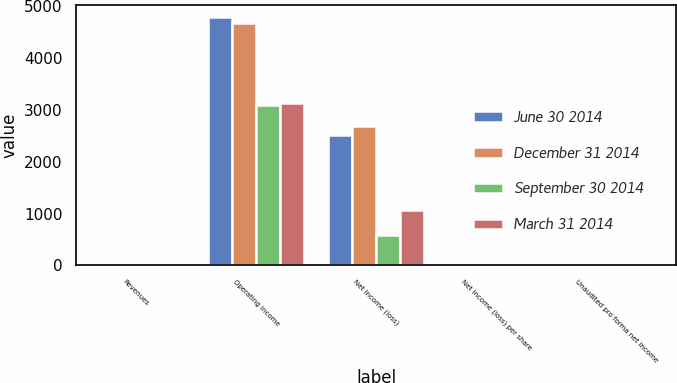<chart> <loc_0><loc_0><loc_500><loc_500><stacked_bar_chart><ecel><fcel>Revenues<fcel>Operating income<fcel>Net income (loss)<fcel>Net income (loss) per share<fcel>Unaudited pro forma net income<nl><fcel>June 30 2014<fcel>0.05<fcel>4787<fcel>2506<fcel>0.05<fcel>0.05<nl><fcel>December 31 2014<fcel>0.05<fcel>4678<fcel>2690<fcel>0.05<fcel>0.05<nl><fcel>September 30 2014<fcel>0.05<fcel>3094<fcel>593<fcel>0.01<fcel>0.01<nl><fcel>March 31 2014<fcel>0.05<fcel>3141<fcel>1060<fcel>0.02<fcel>0.02<nl></chart> 